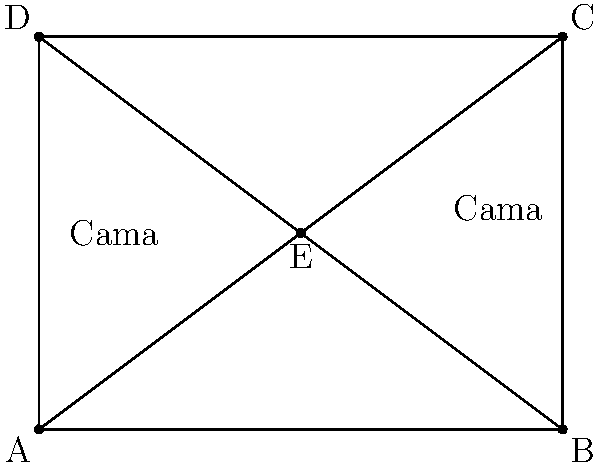En un hospital, se está reorganizando una sala rectangular para optimizar el espacio. La sala se divide en cuatro áreas triangulares utilizando dos líneas diagonales que se cruzan en el centro, como se muestra en la figura. Cada área triangular puede acomodar una cama de hospital. ¿Cuál es el número máximo de camas que se pueden colocar en esta sala si se mantiene esta disposición geométrica? Para resolver este problema, seguiremos estos pasos:

1. Observamos la figura proporcionada. Vemos una sala rectangular dividida en cuatro triángulos por dos líneas diagonales que se cruzan en el centro.

2. Contamos el número de áreas triangulares creadas por las líneas diagonales:
   - Triángulo ABE
   - Triángulo BCE
   - Triángulo CDE
   - Triángulo ADE

3. Cada área triangular puede acomodar una cama de hospital.

4. Contamos el número total de áreas triangulares: hay 4 en total.

5. Como cada área triangular puede acomodar una cama, el número máximo de camas que se pueden colocar es igual al número de áreas triangulares.

Por lo tanto, el número máximo de camas que se pueden colocar en esta sala con esta disposición geométrica es 4.
Answer: 4 camas 